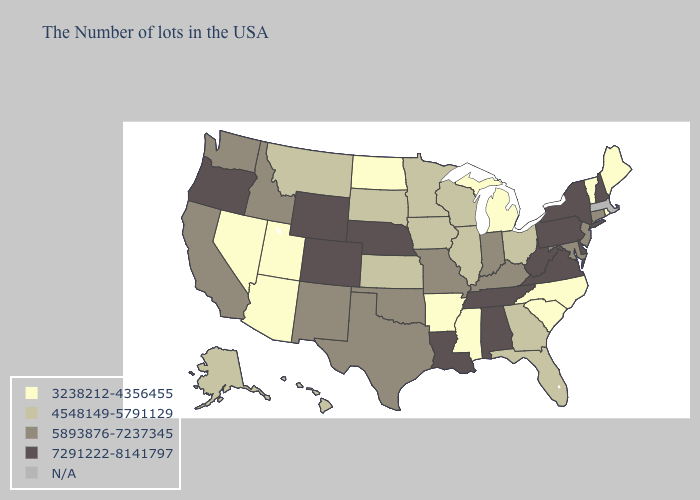What is the highest value in the Northeast ?
Concise answer only. 7291222-8141797. What is the highest value in the West ?
Write a very short answer. 7291222-8141797. What is the value of Oklahoma?
Write a very short answer. 5893876-7237345. Name the states that have a value in the range 4548149-5791129?
Answer briefly. Ohio, Florida, Georgia, Wisconsin, Illinois, Minnesota, Iowa, Kansas, South Dakota, Montana, Alaska, Hawaii. What is the lowest value in the USA?
Quick response, please. 3238212-4356455. Name the states that have a value in the range 5893876-7237345?
Concise answer only. Connecticut, New Jersey, Maryland, Kentucky, Indiana, Missouri, Oklahoma, Texas, New Mexico, Idaho, California, Washington. What is the highest value in states that border Pennsylvania?
Give a very brief answer. 7291222-8141797. Name the states that have a value in the range 3238212-4356455?
Quick response, please. Maine, Rhode Island, Vermont, North Carolina, South Carolina, Michigan, Mississippi, Arkansas, North Dakota, Utah, Arizona, Nevada. Name the states that have a value in the range 3238212-4356455?
Give a very brief answer. Maine, Rhode Island, Vermont, North Carolina, South Carolina, Michigan, Mississippi, Arkansas, North Dakota, Utah, Arizona, Nevada. Does Nevada have the lowest value in the West?
Be succinct. Yes. Does Arizona have the highest value in the West?
Short answer required. No. Among the states that border Tennessee , which have the highest value?
Keep it brief. Virginia, Alabama. Among the states that border Minnesota , does North Dakota have the highest value?
Quick response, please. No. 